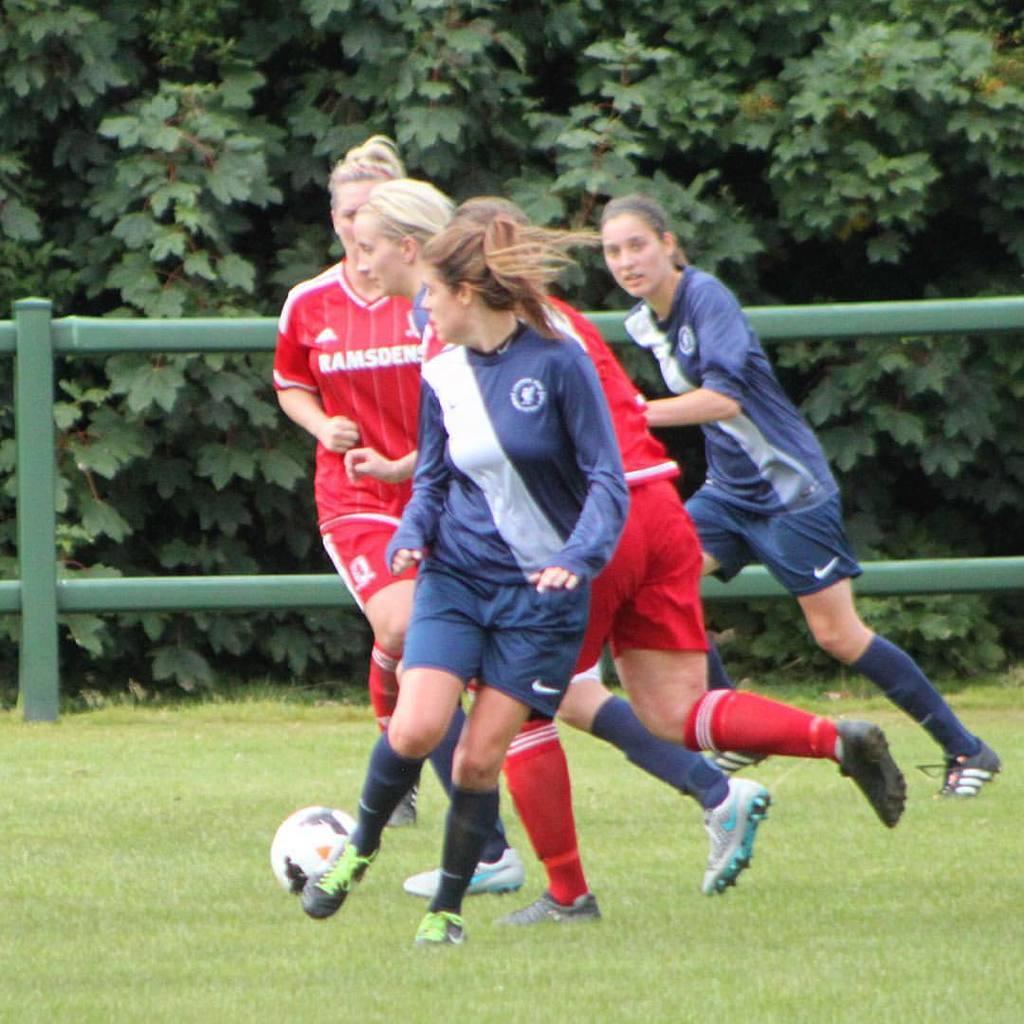In one or two sentences, can you explain what this image depicts? In this picture we can see four woman running at ball on ground and in background we can see trees, fence. 